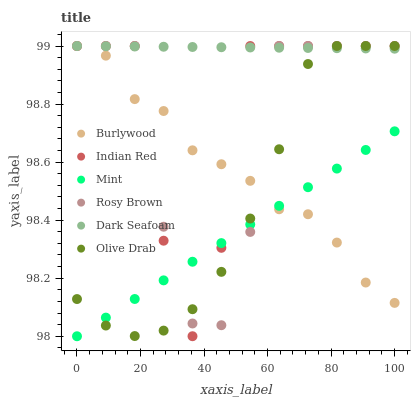Does Mint have the minimum area under the curve?
Answer yes or no. Yes. Does Dark Seafoam have the maximum area under the curve?
Answer yes or no. Yes. Does Rosy Brown have the minimum area under the curve?
Answer yes or no. No. Does Rosy Brown have the maximum area under the curve?
Answer yes or no. No. Is Dark Seafoam the smoothest?
Answer yes or no. Yes. Is Indian Red the roughest?
Answer yes or no. Yes. Is Rosy Brown the smoothest?
Answer yes or no. No. Is Rosy Brown the roughest?
Answer yes or no. No. Does Mint have the lowest value?
Answer yes or no. Yes. Does Rosy Brown have the lowest value?
Answer yes or no. No. Does Olive Drab have the highest value?
Answer yes or no. Yes. Does Mint have the highest value?
Answer yes or no. No. Is Mint less than Dark Seafoam?
Answer yes or no. Yes. Is Dark Seafoam greater than Mint?
Answer yes or no. Yes. Does Mint intersect Indian Red?
Answer yes or no. Yes. Is Mint less than Indian Red?
Answer yes or no. No. Is Mint greater than Indian Red?
Answer yes or no. No. Does Mint intersect Dark Seafoam?
Answer yes or no. No. 